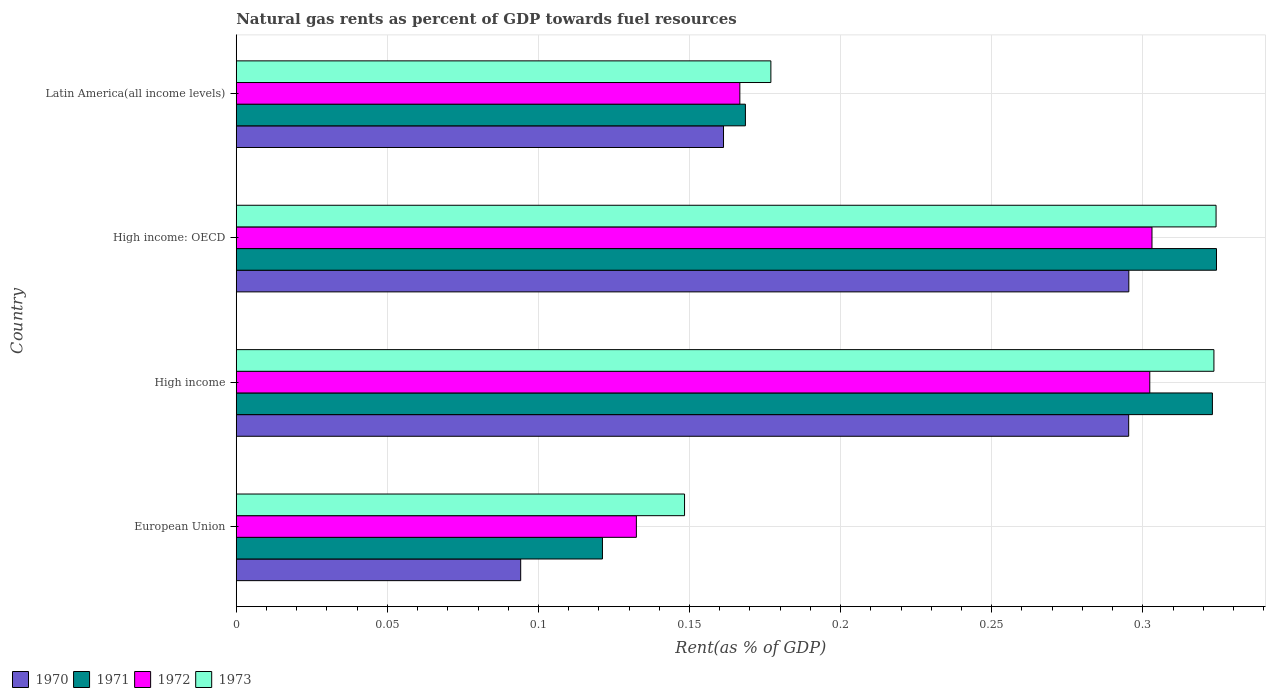How many different coloured bars are there?
Your answer should be compact. 4. How many groups of bars are there?
Your answer should be very brief. 4. What is the label of the 1st group of bars from the top?
Offer a very short reply. Latin America(all income levels). In how many cases, is the number of bars for a given country not equal to the number of legend labels?
Offer a very short reply. 0. What is the matural gas rent in 1970 in High income?
Your answer should be very brief. 0.3. Across all countries, what is the maximum matural gas rent in 1973?
Your response must be concise. 0.32. Across all countries, what is the minimum matural gas rent in 1972?
Provide a short and direct response. 0.13. In which country was the matural gas rent in 1970 maximum?
Make the answer very short. High income: OECD. What is the total matural gas rent in 1972 in the graph?
Offer a terse response. 0.9. What is the difference between the matural gas rent in 1972 in High income and that in High income: OECD?
Keep it short and to the point. -0. What is the difference between the matural gas rent in 1970 in Latin America(all income levels) and the matural gas rent in 1971 in High income: OECD?
Ensure brevity in your answer.  -0.16. What is the average matural gas rent in 1972 per country?
Give a very brief answer. 0.23. What is the difference between the matural gas rent in 1971 and matural gas rent in 1972 in European Union?
Offer a very short reply. -0.01. In how many countries, is the matural gas rent in 1973 greater than 0.21000000000000002 %?
Your response must be concise. 2. What is the ratio of the matural gas rent in 1973 in High income to that in Latin America(all income levels)?
Keep it short and to the point. 1.83. What is the difference between the highest and the second highest matural gas rent in 1970?
Provide a short and direct response. 4.502023738700567e-5. What is the difference between the highest and the lowest matural gas rent in 1970?
Make the answer very short. 0.2. In how many countries, is the matural gas rent in 1970 greater than the average matural gas rent in 1970 taken over all countries?
Offer a very short reply. 2. Is it the case that in every country, the sum of the matural gas rent in 1972 and matural gas rent in 1973 is greater than the matural gas rent in 1970?
Your answer should be compact. Yes. Are all the bars in the graph horizontal?
Give a very brief answer. Yes. How many countries are there in the graph?
Make the answer very short. 4. Are the values on the major ticks of X-axis written in scientific E-notation?
Provide a short and direct response. No. Does the graph contain grids?
Give a very brief answer. Yes. Where does the legend appear in the graph?
Give a very brief answer. Bottom left. How many legend labels are there?
Offer a terse response. 4. What is the title of the graph?
Offer a terse response. Natural gas rents as percent of GDP towards fuel resources. Does "2007" appear as one of the legend labels in the graph?
Provide a short and direct response. No. What is the label or title of the X-axis?
Your response must be concise. Rent(as % of GDP). What is the label or title of the Y-axis?
Give a very brief answer. Country. What is the Rent(as % of GDP) of 1970 in European Union?
Provide a short and direct response. 0.09. What is the Rent(as % of GDP) in 1971 in European Union?
Keep it short and to the point. 0.12. What is the Rent(as % of GDP) in 1972 in European Union?
Ensure brevity in your answer.  0.13. What is the Rent(as % of GDP) in 1973 in European Union?
Your answer should be very brief. 0.15. What is the Rent(as % of GDP) in 1970 in High income?
Make the answer very short. 0.3. What is the Rent(as % of GDP) in 1971 in High income?
Offer a very short reply. 0.32. What is the Rent(as % of GDP) in 1972 in High income?
Your response must be concise. 0.3. What is the Rent(as % of GDP) in 1973 in High income?
Your answer should be very brief. 0.32. What is the Rent(as % of GDP) in 1970 in High income: OECD?
Provide a short and direct response. 0.3. What is the Rent(as % of GDP) of 1971 in High income: OECD?
Your answer should be very brief. 0.32. What is the Rent(as % of GDP) of 1972 in High income: OECD?
Your answer should be very brief. 0.3. What is the Rent(as % of GDP) of 1973 in High income: OECD?
Your response must be concise. 0.32. What is the Rent(as % of GDP) of 1970 in Latin America(all income levels)?
Your answer should be compact. 0.16. What is the Rent(as % of GDP) in 1971 in Latin America(all income levels)?
Your response must be concise. 0.17. What is the Rent(as % of GDP) of 1972 in Latin America(all income levels)?
Offer a terse response. 0.17. What is the Rent(as % of GDP) of 1973 in Latin America(all income levels)?
Offer a very short reply. 0.18. Across all countries, what is the maximum Rent(as % of GDP) in 1970?
Your answer should be very brief. 0.3. Across all countries, what is the maximum Rent(as % of GDP) in 1971?
Offer a terse response. 0.32. Across all countries, what is the maximum Rent(as % of GDP) of 1972?
Offer a terse response. 0.3. Across all countries, what is the maximum Rent(as % of GDP) in 1973?
Your answer should be compact. 0.32. Across all countries, what is the minimum Rent(as % of GDP) in 1970?
Offer a terse response. 0.09. Across all countries, what is the minimum Rent(as % of GDP) in 1971?
Your answer should be very brief. 0.12. Across all countries, what is the minimum Rent(as % of GDP) in 1972?
Provide a succinct answer. 0.13. Across all countries, what is the minimum Rent(as % of GDP) of 1973?
Offer a terse response. 0.15. What is the total Rent(as % of GDP) of 1970 in the graph?
Keep it short and to the point. 0.85. What is the total Rent(as % of GDP) of 1971 in the graph?
Give a very brief answer. 0.94. What is the total Rent(as % of GDP) of 1972 in the graph?
Make the answer very short. 0.9. What is the total Rent(as % of GDP) of 1973 in the graph?
Your answer should be very brief. 0.97. What is the difference between the Rent(as % of GDP) of 1970 in European Union and that in High income?
Keep it short and to the point. -0.2. What is the difference between the Rent(as % of GDP) of 1971 in European Union and that in High income?
Offer a terse response. -0.2. What is the difference between the Rent(as % of GDP) in 1972 in European Union and that in High income?
Make the answer very short. -0.17. What is the difference between the Rent(as % of GDP) of 1973 in European Union and that in High income?
Give a very brief answer. -0.18. What is the difference between the Rent(as % of GDP) of 1970 in European Union and that in High income: OECD?
Your response must be concise. -0.2. What is the difference between the Rent(as % of GDP) of 1971 in European Union and that in High income: OECD?
Your response must be concise. -0.2. What is the difference between the Rent(as % of GDP) in 1972 in European Union and that in High income: OECD?
Provide a short and direct response. -0.17. What is the difference between the Rent(as % of GDP) in 1973 in European Union and that in High income: OECD?
Ensure brevity in your answer.  -0.18. What is the difference between the Rent(as % of GDP) in 1970 in European Union and that in Latin America(all income levels)?
Your answer should be very brief. -0.07. What is the difference between the Rent(as % of GDP) of 1971 in European Union and that in Latin America(all income levels)?
Make the answer very short. -0.05. What is the difference between the Rent(as % of GDP) of 1972 in European Union and that in Latin America(all income levels)?
Your response must be concise. -0.03. What is the difference between the Rent(as % of GDP) of 1973 in European Union and that in Latin America(all income levels)?
Give a very brief answer. -0.03. What is the difference between the Rent(as % of GDP) in 1971 in High income and that in High income: OECD?
Your response must be concise. -0. What is the difference between the Rent(as % of GDP) in 1972 in High income and that in High income: OECD?
Provide a succinct answer. -0. What is the difference between the Rent(as % of GDP) of 1973 in High income and that in High income: OECD?
Your answer should be compact. -0. What is the difference between the Rent(as % of GDP) of 1970 in High income and that in Latin America(all income levels)?
Ensure brevity in your answer.  0.13. What is the difference between the Rent(as % of GDP) of 1971 in High income and that in Latin America(all income levels)?
Give a very brief answer. 0.15. What is the difference between the Rent(as % of GDP) in 1972 in High income and that in Latin America(all income levels)?
Your response must be concise. 0.14. What is the difference between the Rent(as % of GDP) of 1973 in High income and that in Latin America(all income levels)?
Your answer should be very brief. 0.15. What is the difference between the Rent(as % of GDP) in 1970 in High income: OECD and that in Latin America(all income levels)?
Your answer should be very brief. 0.13. What is the difference between the Rent(as % of GDP) of 1971 in High income: OECD and that in Latin America(all income levels)?
Your response must be concise. 0.16. What is the difference between the Rent(as % of GDP) in 1972 in High income: OECD and that in Latin America(all income levels)?
Keep it short and to the point. 0.14. What is the difference between the Rent(as % of GDP) in 1973 in High income: OECD and that in Latin America(all income levels)?
Offer a terse response. 0.15. What is the difference between the Rent(as % of GDP) of 1970 in European Union and the Rent(as % of GDP) of 1971 in High income?
Make the answer very short. -0.23. What is the difference between the Rent(as % of GDP) in 1970 in European Union and the Rent(as % of GDP) in 1972 in High income?
Your answer should be very brief. -0.21. What is the difference between the Rent(as % of GDP) of 1970 in European Union and the Rent(as % of GDP) of 1973 in High income?
Provide a succinct answer. -0.23. What is the difference between the Rent(as % of GDP) of 1971 in European Union and the Rent(as % of GDP) of 1972 in High income?
Give a very brief answer. -0.18. What is the difference between the Rent(as % of GDP) of 1971 in European Union and the Rent(as % of GDP) of 1973 in High income?
Your answer should be very brief. -0.2. What is the difference between the Rent(as % of GDP) in 1972 in European Union and the Rent(as % of GDP) in 1973 in High income?
Your answer should be very brief. -0.19. What is the difference between the Rent(as % of GDP) in 1970 in European Union and the Rent(as % of GDP) in 1971 in High income: OECD?
Provide a short and direct response. -0.23. What is the difference between the Rent(as % of GDP) of 1970 in European Union and the Rent(as % of GDP) of 1972 in High income: OECD?
Offer a terse response. -0.21. What is the difference between the Rent(as % of GDP) of 1970 in European Union and the Rent(as % of GDP) of 1973 in High income: OECD?
Keep it short and to the point. -0.23. What is the difference between the Rent(as % of GDP) in 1971 in European Union and the Rent(as % of GDP) in 1972 in High income: OECD?
Provide a succinct answer. -0.18. What is the difference between the Rent(as % of GDP) in 1971 in European Union and the Rent(as % of GDP) in 1973 in High income: OECD?
Your response must be concise. -0.2. What is the difference between the Rent(as % of GDP) in 1972 in European Union and the Rent(as % of GDP) in 1973 in High income: OECD?
Your answer should be compact. -0.19. What is the difference between the Rent(as % of GDP) of 1970 in European Union and the Rent(as % of GDP) of 1971 in Latin America(all income levels)?
Your answer should be very brief. -0.07. What is the difference between the Rent(as % of GDP) in 1970 in European Union and the Rent(as % of GDP) in 1972 in Latin America(all income levels)?
Give a very brief answer. -0.07. What is the difference between the Rent(as % of GDP) in 1970 in European Union and the Rent(as % of GDP) in 1973 in Latin America(all income levels)?
Offer a very short reply. -0.08. What is the difference between the Rent(as % of GDP) of 1971 in European Union and the Rent(as % of GDP) of 1972 in Latin America(all income levels)?
Your response must be concise. -0.05. What is the difference between the Rent(as % of GDP) in 1971 in European Union and the Rent(as % of GDP) in 1973 in Latin America(all income levels)?
Your answer should be very brief. -0.06. What is the difference between the Rent(as % of GDP) in 1972 in European Union and the Rent(as % of GDP) in 1973 in Latin America(all income levels)?
Provide a succinct answer. -0.04. What is the difference between the Rent(as % of GDP) in 1970 in High income and the Rent(as % of GDP) in 1971 in High income: OECD?
Offer a very short reply. -0.03. What is the difference between the Rent(as % of GDP) in 1970 in High income and the Rent(as % of GDP) in 1972 in High income: OECD?
Provide a succinct answer. -0.01. What is the difference between the Rent(as % of GDP) in 1970 in High income and the Rent(as % of GDP) in 1973 in High income: OECD?
Provide a short and direct response. -0.03. What is the difference between the Rent(as % of GDP) in 1971 in High income and the Rent(as % of GDP) in 1973 in High income: OECD?
Provide a short and direct response. -0. What is the difference between the Rent(as % of GDP) in 1972 in High income and the Rent(as % of GDP) in 1973 in High income: OECD?
Provide a succinct answer. -0.02. What is the difference between the Rent(as % of GDP) of 1970 in High income and the Rent(as % of GDP) of 1971 in Latin America(all income levels)?
Your response must be concise. 0.13. What is the difference between the Rent(as % of GDP) in 1970 in High income and the Rent(as % of GDP) in 1972 in Latin America(all income levels)?
Ensure brevity in your answer.  0.13. What is the difference between the Rent(as % of GDP) of 1970 in High income and the Rent(as % of GDP) of 1973 in Latin America(all income levels)?
Make the answer very short. 0.12. What is the difference between the Rent(as % of GDP) in 1971 in High income and the Rent(as % of GDP) in 1972 in Latin America(all income levels)?
Keep it short and to the point. 0.16. What is the difference between the Rent(as % of GDP) of 1971 in High income and the Rent(as % of GDP) of 1973 in Latin America(all income levels)?
Give a very brief answer. 0.15. What is the difference between the Rent(as % of GDP) of 1972 in High income and the Rent(as % of GDP) of 1973 in Latin America(all income levels)?
Give a very brief answer. 0.13. What is the difference between the Rent(as % of GDP) in 1970 in High income: OECD and the Rent(as % of GDP) in 1971 in Latin America(all income levels)?
Your answer should be very brief. 0.13. What is the difference between the Rent(as % of GDP) of 1970 in High income: OECD and the Rent(as % of GDP) of 1972 in Latin America(all income levels)?
Offer a very short reply. 0.13. What is the difference between the Rent(as % of GDP) in 1970 in High income: OECD and the Rent(as % of GDP) in 1973 in Latin America(all income levels)?
Your answer should be compact. 0.12. What is the difference between the Rent(as % of GDP) of 1971 in High income: OECD and the Rent(as % of GDP) of 1972 in Latin America(all income levels)?
Ensure brevity in your answer.  0.16. What is the difference between the Rent(as % of GDP) of 1971 in High income: OECD and the Rent(as % of GDP) of 1973 in Latin America(all income levels)?
Provide a short and direct response. 0.15. What is the difference between the Rent(as % of GDP) in 1972 in High income: OECD and the Rent(as % of GDP) in 1973 in Latin America(all income levels)?
Your answer should be very brief. 0.13. What is the average Rent(as % of GDP) of 1970 per country?
Make the answer very short. 0.21. What is the average Rent(as % of GDP) of 1971 per country?
Your answer should be compact. 0.23. What is the average Rent(as % of GDP) in 1972 per country?
Your answer should be compact. 0.23. What is the average Rent(as % of GDP) in 1973 per country?
Your answer should be compact. 0.24. What is the difference between the Rent(as % of GDP) of 1970 and Rent(as % of GDP) of 1971 in European Union?
Offer a very short reply. -0.03. What is the difference between the Rent(as % of GDP) in 1970 and Rent(as % of GDP) in 1972 in European Union?
Keep it short and to the point. -0.04. What is the difference between the Rent(as % of GDP) in 1970 and Rent(as % of GDP) in 1973 in European Union?
Keep it short and to the point. -0.05. What is the difference between the Rent(as % of GDP) of 1971 and Rent(as % of GDP) of 1972 in European Union?
Offer a terse response. -0.01. What is the difference between the Rent(as % of GDP) in 1971 and Rent(as % of GDP) in 1973 in European Union?
Keep it short and to the point. -0.03. What is the difference between the Rent(as % of GDP) in 1972 and Rent(as % of GDP) in 1973 in European Union?
Give a very brief answer. -0.02. What is the difference between the Rent(as % of GDP) in 1970 and Rent(as % of GDP) in 1971 in High income?
Give a very brief answer. -0.03. What is the difference between the Rent(as % of GDP) in 1970 and Rent(as % of GDP) in 1972 in High income?
Ensure brevity in your answer.  -0.01. What is the difference between the Rent(as % of GDP) of 1970 and Rent(as % of GDP) of 1973 in High income?
Your response must be concise. -0.03. What is the difference between the Rent(as % of GDP) of 1971 and Rent(as % of GDP) of 1972 in High income?
Your response must be concise. 0.02. What is the difference between the Rent(as % of GDP) of 1971 and Rent(as % of GDP) of 1973 in High income?
Ensure brevity in your answer.  -0. What is the difference between the Rent(as % of GDP) of 1972 and Rent(as % of GDP) of 1973 in High income?
Ensure brevity in your answer.  -0.02. What is the difference between the Rent(as % of GDP) in 1970 and Rent(as % of GDP) in 1971 in High income: OECD?
Provide a succinct answer. -0.03. What is the difference between the Rent(as % of GDP) in 1970 and Rent(as % of GDP) in 1972 in High income: OECD?
Give a very brief answer. -0.01. What is the difference between the Rent(as % of GDP) of 1970 and Rent(as % of GDP) of 1973 in High income: OECD?
Give a very brief answer. -0.03. What is the difference between the Rent(as % of GDP) in 1971 and Rent(as % of GDP) in 1972 in High income: OECD?
Provide a succinct answer. 0.02. What is the difference between the Rent(as % of GDP) in 1972 and Rent(as % of GDP) in 1973 in High income: OECD?
Your answer should be compact. -0.02. What is the difference between the Rent(as % of GDP) of 1970 and Rent(as % of GDP) of 1971 in Latin America(all income levels)?
Your answer should be compact. -0.01. What is the difference between the Rent(as % of GDP) of 1970 and Rent(as % of GDP) of 1972 in Latin America(all income levels)?
Your answer should be very brief. -0.01. What is the difference between the Rent(as % of GDP) of 1970 and Rent(as % of GDP) of 1973 in Latin America(all income levels)?
Offer a very short reply. -0.02. What is the difference between the Rent(as % of GDP) in 1971 and Rent(as % of GDP) in 1972 in Latin America(all income levels)?
Keep it short and to the point. 0. What is the difference between the Rent(as % of GDP) in 1971 and Rent(as % of GDP) in 1973 in Latin America(all income levels)?
Keep it short and to the point. -0.01. What is the difference between the Rent(as % of GDP) of 1972 and Rent(as % of GDP) of 1973 in Latin America(all income levels)?
Your answer should be compact. -0.01. What is the ratio of the Rent(as % of GDP) in 1970 in European Union to that in High income?
Offer a very short reply. 0.32. What is the ratio of the Rent(as % of GDP) in 1971 in European Union to that in High income?
Your answer should be very brief. 0.38. What is the ratio of the Rent(as % of GDP) in 1972 in European Union to that in High income?
Provide a short and direct response. 0.44. What is the ratio of the Rent(as % of GDP) in 1973 in European Union to that in High income?
Your response must be concise. 0.46. What is the ratio of the Rent(as % of GDP) in 1970 in European Union to that in High income: OECD?
Offer a terse response. 0.32. What is the ratio of the Rent(as % of GDP) of 1971 in European Union to that in High income: OECD?
Provide a short and direct response. 0.37. What is the ratio of the Rent(as % of GDP) in 1972 in European Union to that in High income: OECD?
Ensure brevity in your answer.  0.44. What is the ratio of the Rent(as % of GDP) in 1973 in European Union to that in High income: OECD?
Make the answer very short. 0.46. What is the ratio of the Rent(as % of GDP) of 1970 in European Union to that in Latin America(all income levels)?
Your answer should be very brief. 0.58. What is the ratio of the Rent(as % of GDP) in 1971 in European Union to that in Latin America(all income levels)?
Give a very brief answer. 0.72. What is the ratio of the Rent(as % of GDP) in 1972 in European Union to that in Latin America(all income levels)?
Your response must be concise. 0.79. What is the ratio of the Rent(as % of GDP) of 1973 in European Union to that in Latin America(all income levels)?
Give a very brief answer. 0.84. What is the ratio of the Rent(as % of GDP) in 1970 in High income to that in High income: OECD?
Offer a very short reply. 1. What is the ratio of the Rent(as % of GDP) of 1972 in High income to that in High income: OECD?
Your response must be concise. 1. What is the ratio of the Rent(as % of GDP) in 1973 in High income to that in High income: OECD?
Offer a very short reply. 1. What is the ratio of the Rent(as % of GDP) in 1970 in High income to that in Latin America(all income levels)?
Provide a succinct answer. 1.83. What is the ratio of the Rent(as % of GDP) in 1971 in High income to that in Latin America(all income levels)?
Ensure brevity in your answer.  1.92. What is the ratio of the Rent(as % of GDP) in 1972 in High income to that in Latin America(all income levels)?
Make the answer very short. 1.81. What is the ratio of the Rent(as % of GDP) in 1973 in High income to that in Latin America(all income levels)?
Your answer should be compact. 1.83. What is the ratio of the Rent(as % of GDP) of 1970 in High income: OECD to that in Latin America(all income levels)?
Make the answer very short. 1.83. What is the ratio of the Rent(as % of GDP) in 1971 in High income: OECD to that in Latin America(all income levels)?
Make the answer very short. 1.93. What is the ratio of the Rent(as % of GDP) of 1972 in High income: OECD to that in Latin America(all income levels)?
Your answer should be very brief. 1.82. What is the ratio of the Rent(as % of GDP) in 1973 in High income: OECD to that in Latin America(all income levels)?
Your answer should be compact. 1.83. What is the difference between the highest and the second highest Rent(as % of GDP) in 1971?
Provide a succinct answer. 0. What is the difference between the highest and the second highest Rent(as % of GDP) of 1972?
Give a very brief answer. 0. What is the difference between the highest and the second highest Rent(as % of GDP) of 1973?
Your answer should be compact. 0. What is the difference between the highest and the lowest Rent(as % of GDP) of 1970?
Ensure brevity in your answer.  0.2. What is the difference between the highest and the lowest Rent(as % of GDP) in 1971?
Your answer should be compact. 0.2. What is the difference between the highest and the lowest Rent(as % of GDP) in 1972?
Make the answer very short. 0.17. What is the difference between the highest and the lowest Rent(as % of GDP) of 1973?
Your answer should be very brief. 0.18. 